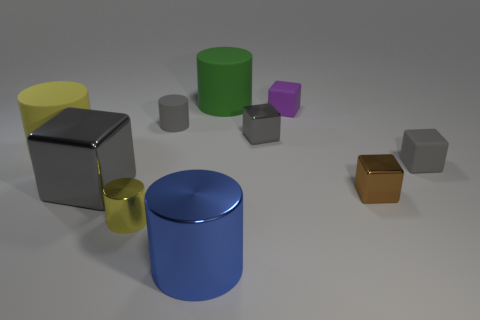Subtract all gray shiny cubes. How many cubes are left? 3 Subtract all blue cylinders. How many cylinders are left? 4 Subtract all green cylinders. How many yellow blocks are left? 0 Add 6 big gray cubes. How many big gray cubes exist? 7 Subtract 0 brown balls. How many objects are left? 10 Subtract 3 cylinders. How many cylinders are left? 2 Subtract all yellow cylinders. Subtract all cyan cubes. How many cylinders are left? 3 Subtract all brown cubes. Subtract all big shiny cylinders. How many objects are left? 8 Add 8 large gray shiny things. How many large gray shiny things are left? 9 